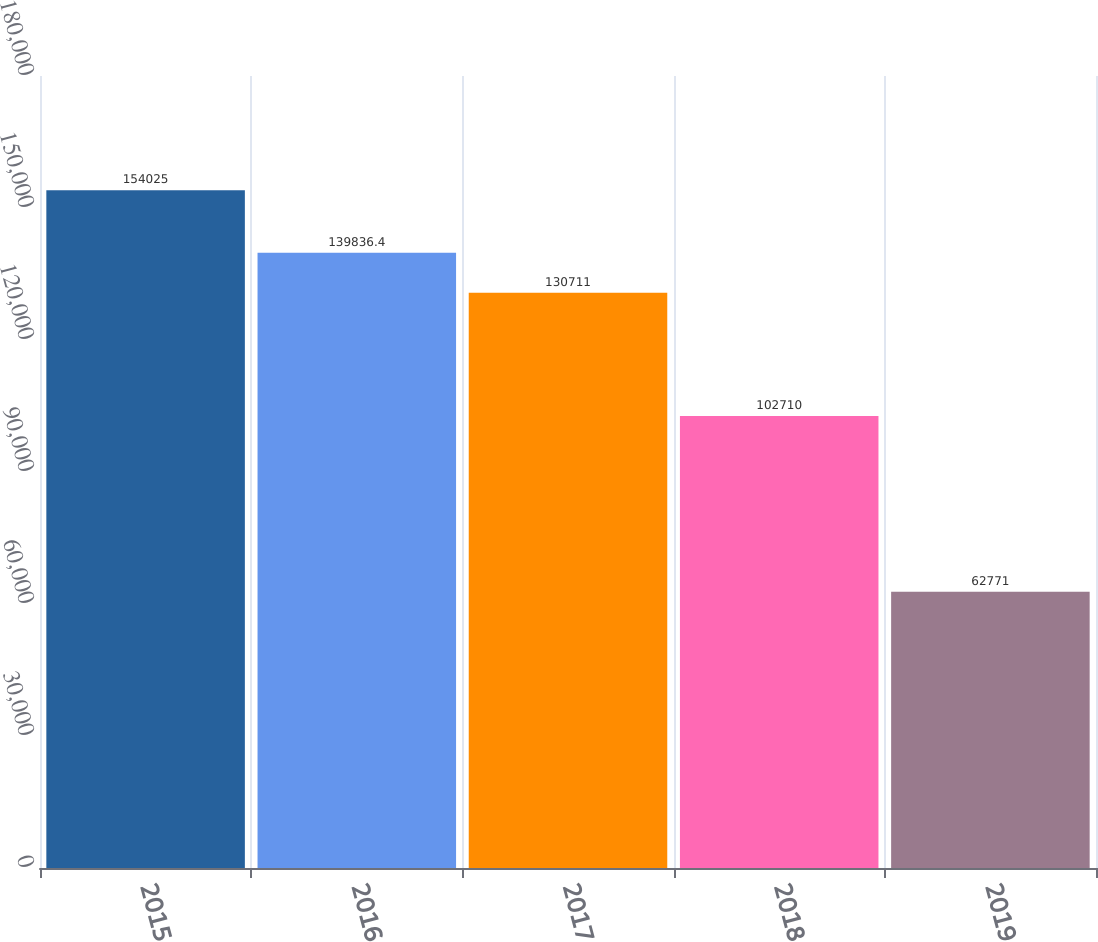Convert chart. <chart><loc_0><loc_0><loc_500><loc_500><bar_chart><fcel>2015<fcel>2016<fcel>2017<fcel>2018<fcel>2019<nl><fcel>154025<fcel>139836<fcel>130711<fcel>102710<fcel>62771<nl></chart> 